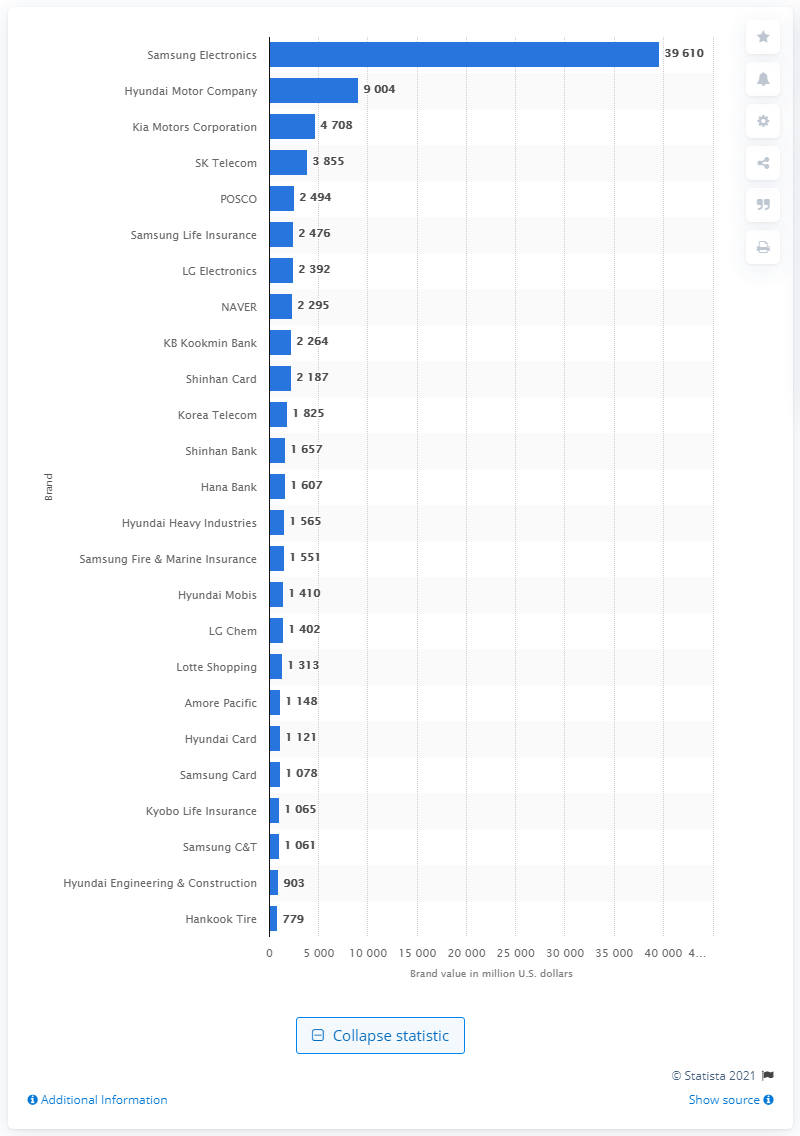Point out several critical features in this image. The estimated value of Samsung Electronics is approximately 39,610. Samsung Electronics is the most valuable Korean brand. 